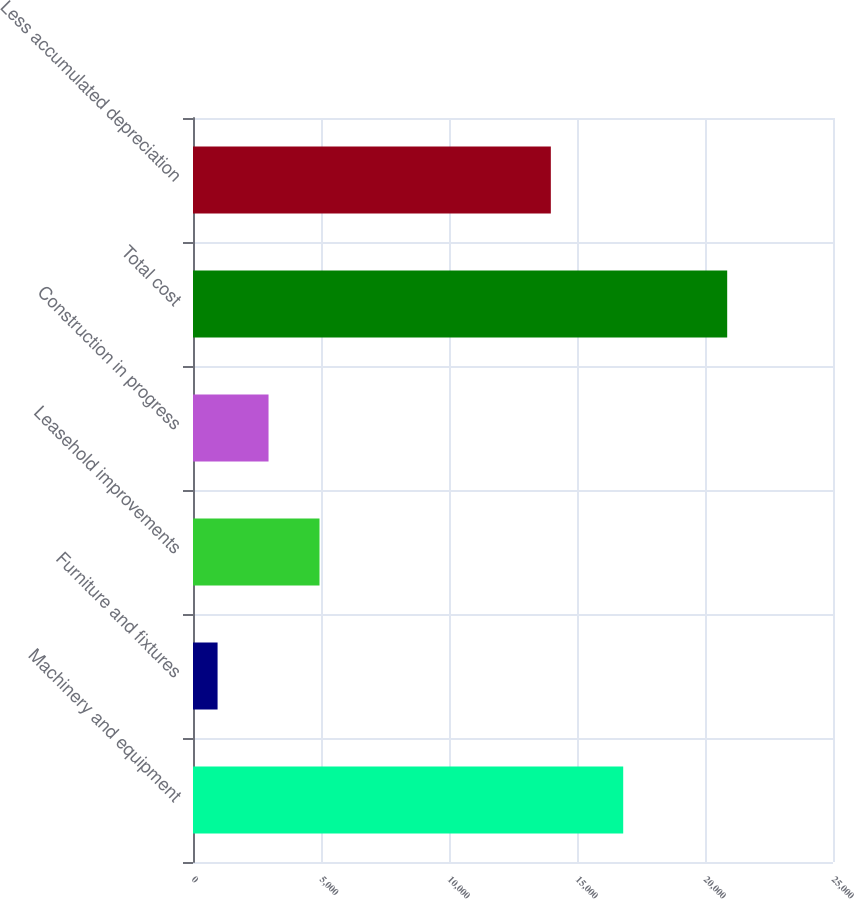Convert chart to OTSL. <chart><loc_0><loc_0><loc_500><loc_500><bar_chart><fcel>Machinery and equipment<fcel>Furniture and fixtures<fcel>Leasehold improvements<fcel>Construction in progress<fcel>Total cost<fcel>Less accumulated depreciation<nl><fcel>16805<fcel>960<fcel>4941.4<fcel>2950.7<fcel>20867<fcel>13978<nl></chart> 